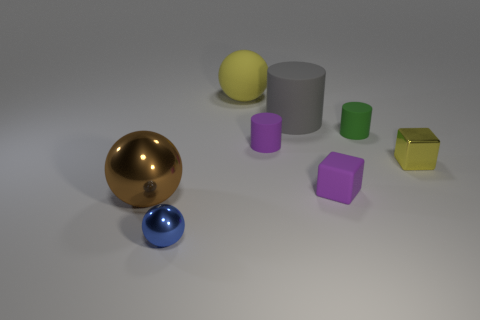Subtract all tiny green cylinders. How many cylinders are left? 2 Add 2 large blue metal spheres. How many objects exist? 10 Subtract all purple cubes. How many cubes are left? 1 Subtract all balls. How many objects are left? 5 Subtract all gray blocks. Subtract all yellow cylinders. How many blocks are left? 2 Subtract all brown blocks. How many green cylinders are left? 1 Add 5 metallic cubes. How many metallic cubes are left? 6 Add 2 metallic balls. How many metallic balls exist? 4 Subtract 0 blue cylinders. How many objects are left? 8 Subtract 1 spheres. How many spheres are left? 2 